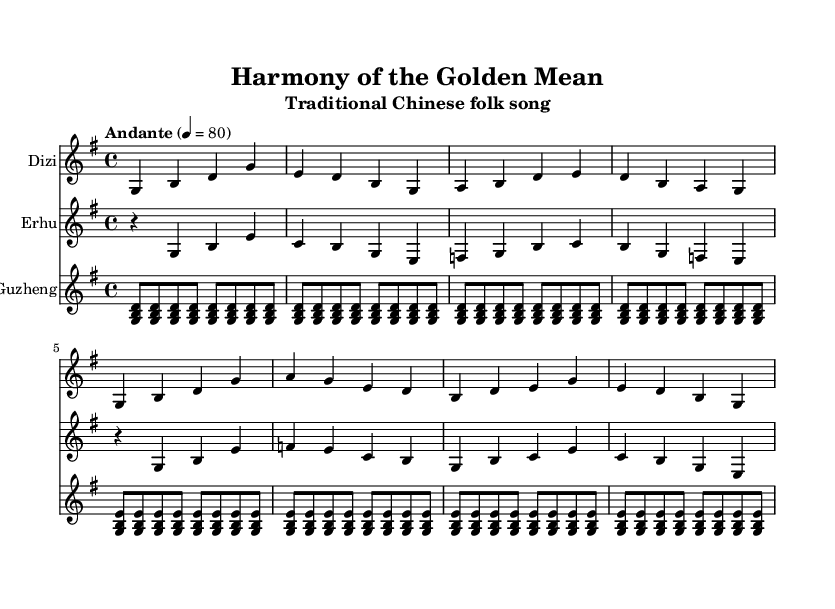What is the key signature of this music? The key signature is G major, which has one sharp (F#). This is identified from the global music context in the code where it's defined under `\key g \major`.
Answer: G major What is the time signature of this piece? The time signature is 4/4, as indicated in the global section of the code with `\time 4/4`. This means there are four beats in each measure, and a quarter note gets one beat.
Answer: 4/4 What is the tempo marking for this composition? The tempo marking is "Andante," which indicates a moderate pace. This is noted in the global context as `\tempo "Andante" 4 = 80`, meaning it has a specific metronomic speed.
Answer: Andante How many measures are in the Dizi part? The Dizi part contains eight measures. This can be counted by looking at the `\relative c' {}` section for Dizi music and counting the groups of notes divided by vertical lines.
Answer: 8 What lyric is associated with the first measure of the Dizi part? The lyric associated with the first measure is "中." This can be determined by examining the lyrics under the `\new Lyrics \lyricsto "diziMusic"` section and correlating it with the notes played in the Dizi part.
Answer: 中 Which instrument plays the melody in the highest register? The Guzheng plays the melody in the highest register. By comparing the pitch ranges of the notes in the three different parts, it is clear that the Guzheng plays higher chords than the other instruments.
Answer: Guzheng What Confucian value does this song prominently feature? The song prominently features "Harmony," indicated in the title and lyrics. Analyzing the lyrics, the focus on social harmony and traditional values reflects the essence of Confucian teachings.
Answer: Harmony 